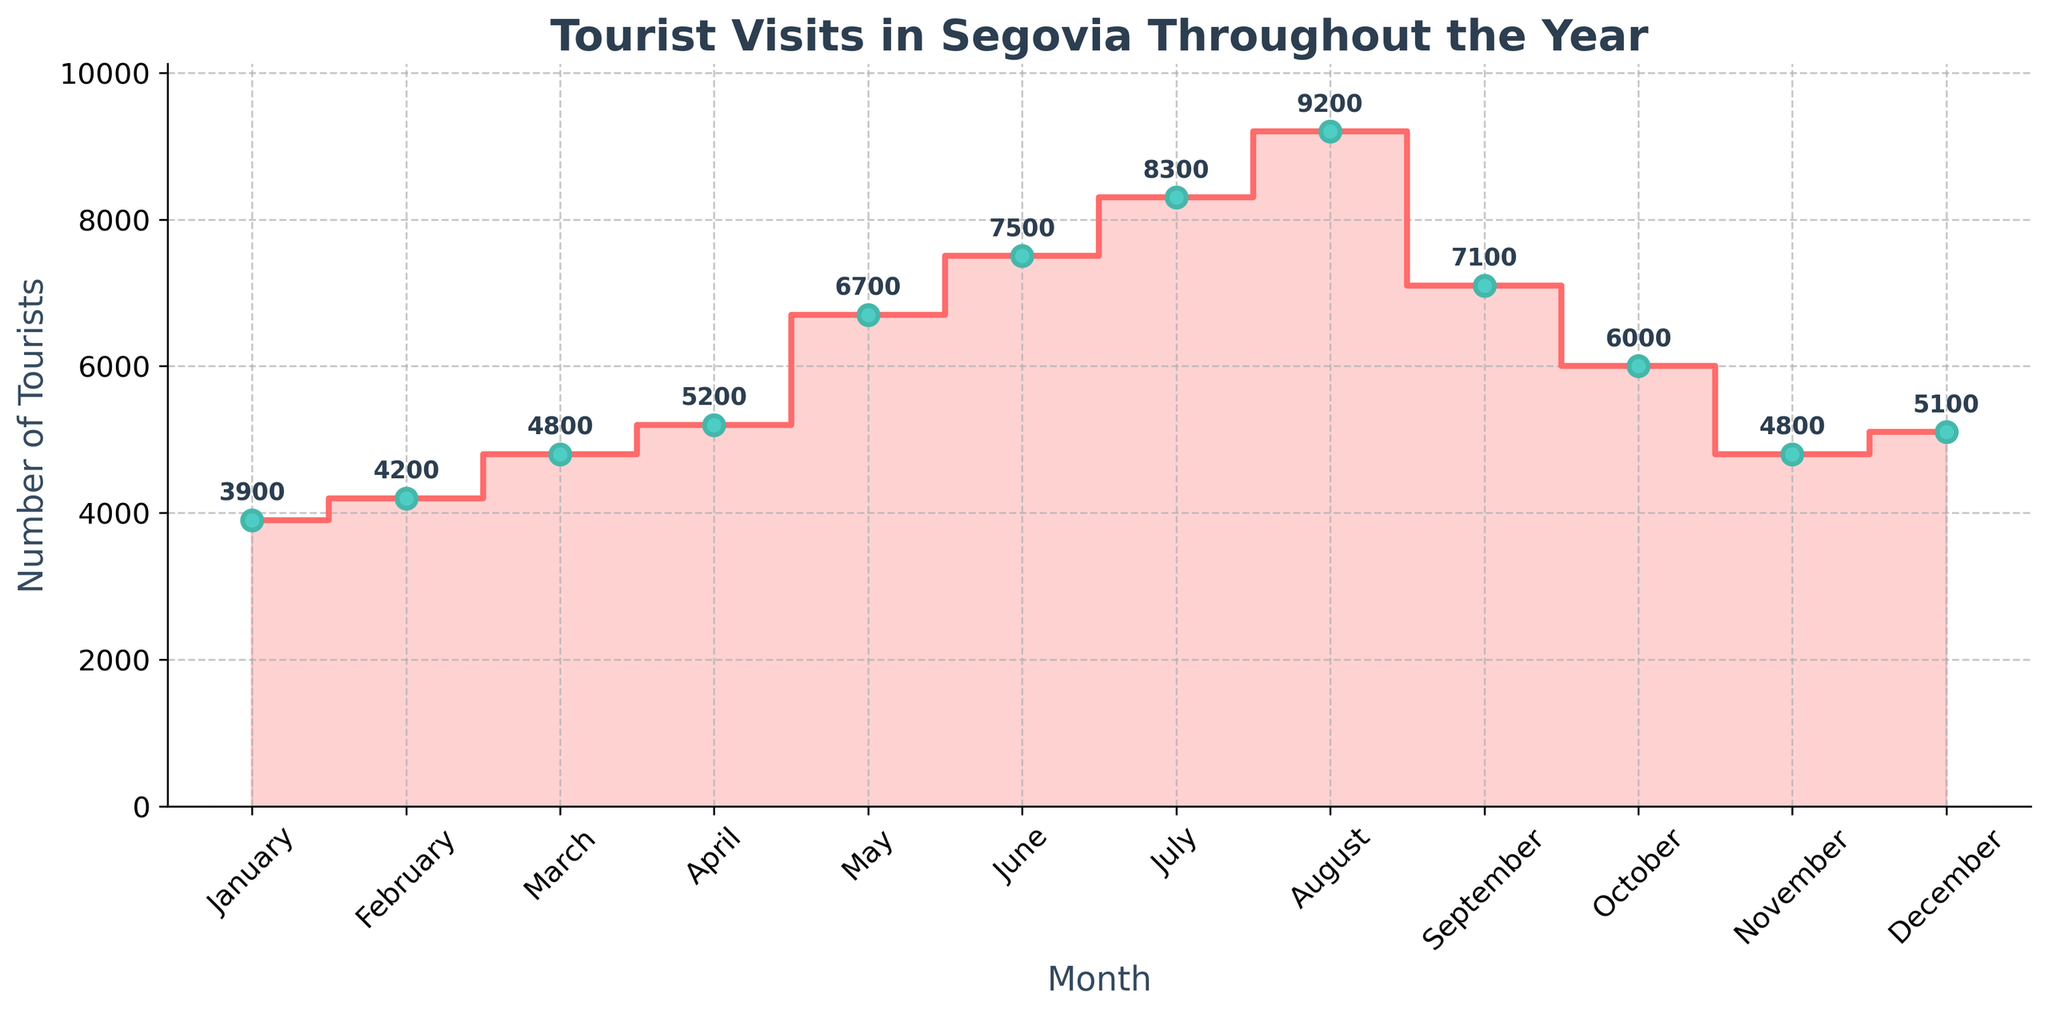What month has the highest number of tourist visits? Look for the month with the highest marker point on the plot. August has the highest point.
Answer: August What is the number of tourist visits in March? Locate March on the x-axis, then look at the corresponding point on the y-axis. The number is given directly above the point.
Answer: 4800 How many more tourists visited in June compared to February? Find the number of tourists in June and February (7500 and 4200 respectively) and subtract February's number from June's number: 7500 - 4200 = 3300
Answer: 3300 Which months have fewer than 5000 tourist visits? Identify the months where the marker points are below the 5000 mark on the y-axis. These months are January, February, March, November, and December.
Answer: January, February, March, November, December What is the average number of tourist visits across the year? Sum all the tourist visits numbers provided, then divide by the number of months (12). The sum is 68000, so the average is 68000/12 = 5666.66
Answer: 5667 Which month experienced the largest increase in tourist visits compared to the previous month? Check the difference in visits between consecutive months and identify the largest increase. May to June has the highest increase (7500 - 6700 = 800).
Answer: June What trends can you observe in tourist visits in the summer months? Look at the values from June to August. There is a consistent increase from June to August.
Answer: Consistent increase How does October's tourist visits compare with April's? Compare the y-values for October (6000) and April (5200). October has more visits than April.
Answer: October has more What month follows after the peak tourist visits? Identify the peak month (August) and look at the next month on the x-axis (September).
Answer: September How many months saw an increase in tourist visits compared to the previous month? Compare values for each month sequentially to see if there is an increase. There are increases in February, March, April, May, June, July, and August, so 7 months.
Answer: 7 